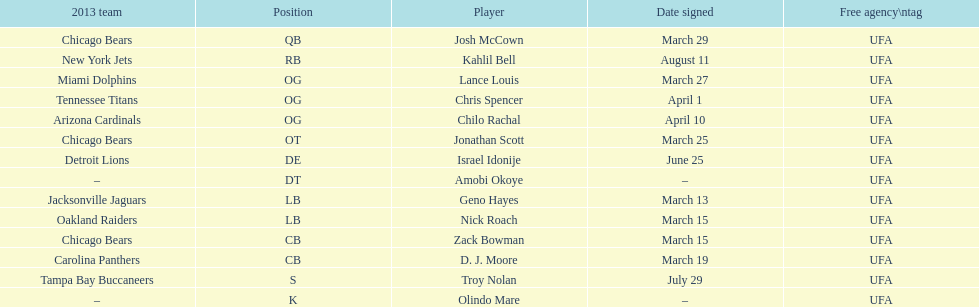Last name is also a first name beginning with "n" Troy Nolan. 